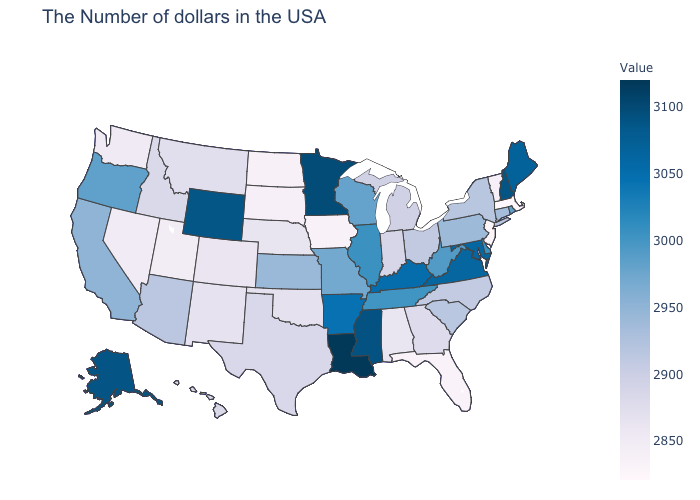Which states hav the highest value in the South?
Keep it brief. Louisiana. Which states have the highest value in the USA?
Concise answer only. Louisiana. Which states have the lowest value in the USA?
Give a very brief answer. Massachusetts. Does Utah have the lowest value in the West?
Give a very brief answer. Yes. Does Oklahoma have a higher value than New Jersey?
Quick response, please. Yes. Does Iowa have the lowest value in the MidWest?
Write a very short answer. Yes. 